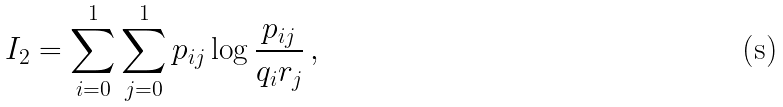Convert formula to latex. <formula><loc_0><loc_0><loc_500><loc_500>I _ { 2 } = \sum _ { i = 0 } ^ { 1 } \sum _ { j = 0 } ^ { 1 } p _ { i j } \log \frac { p _ { i j } } { q _ { i } r _ { j } } \, ,</formula> 